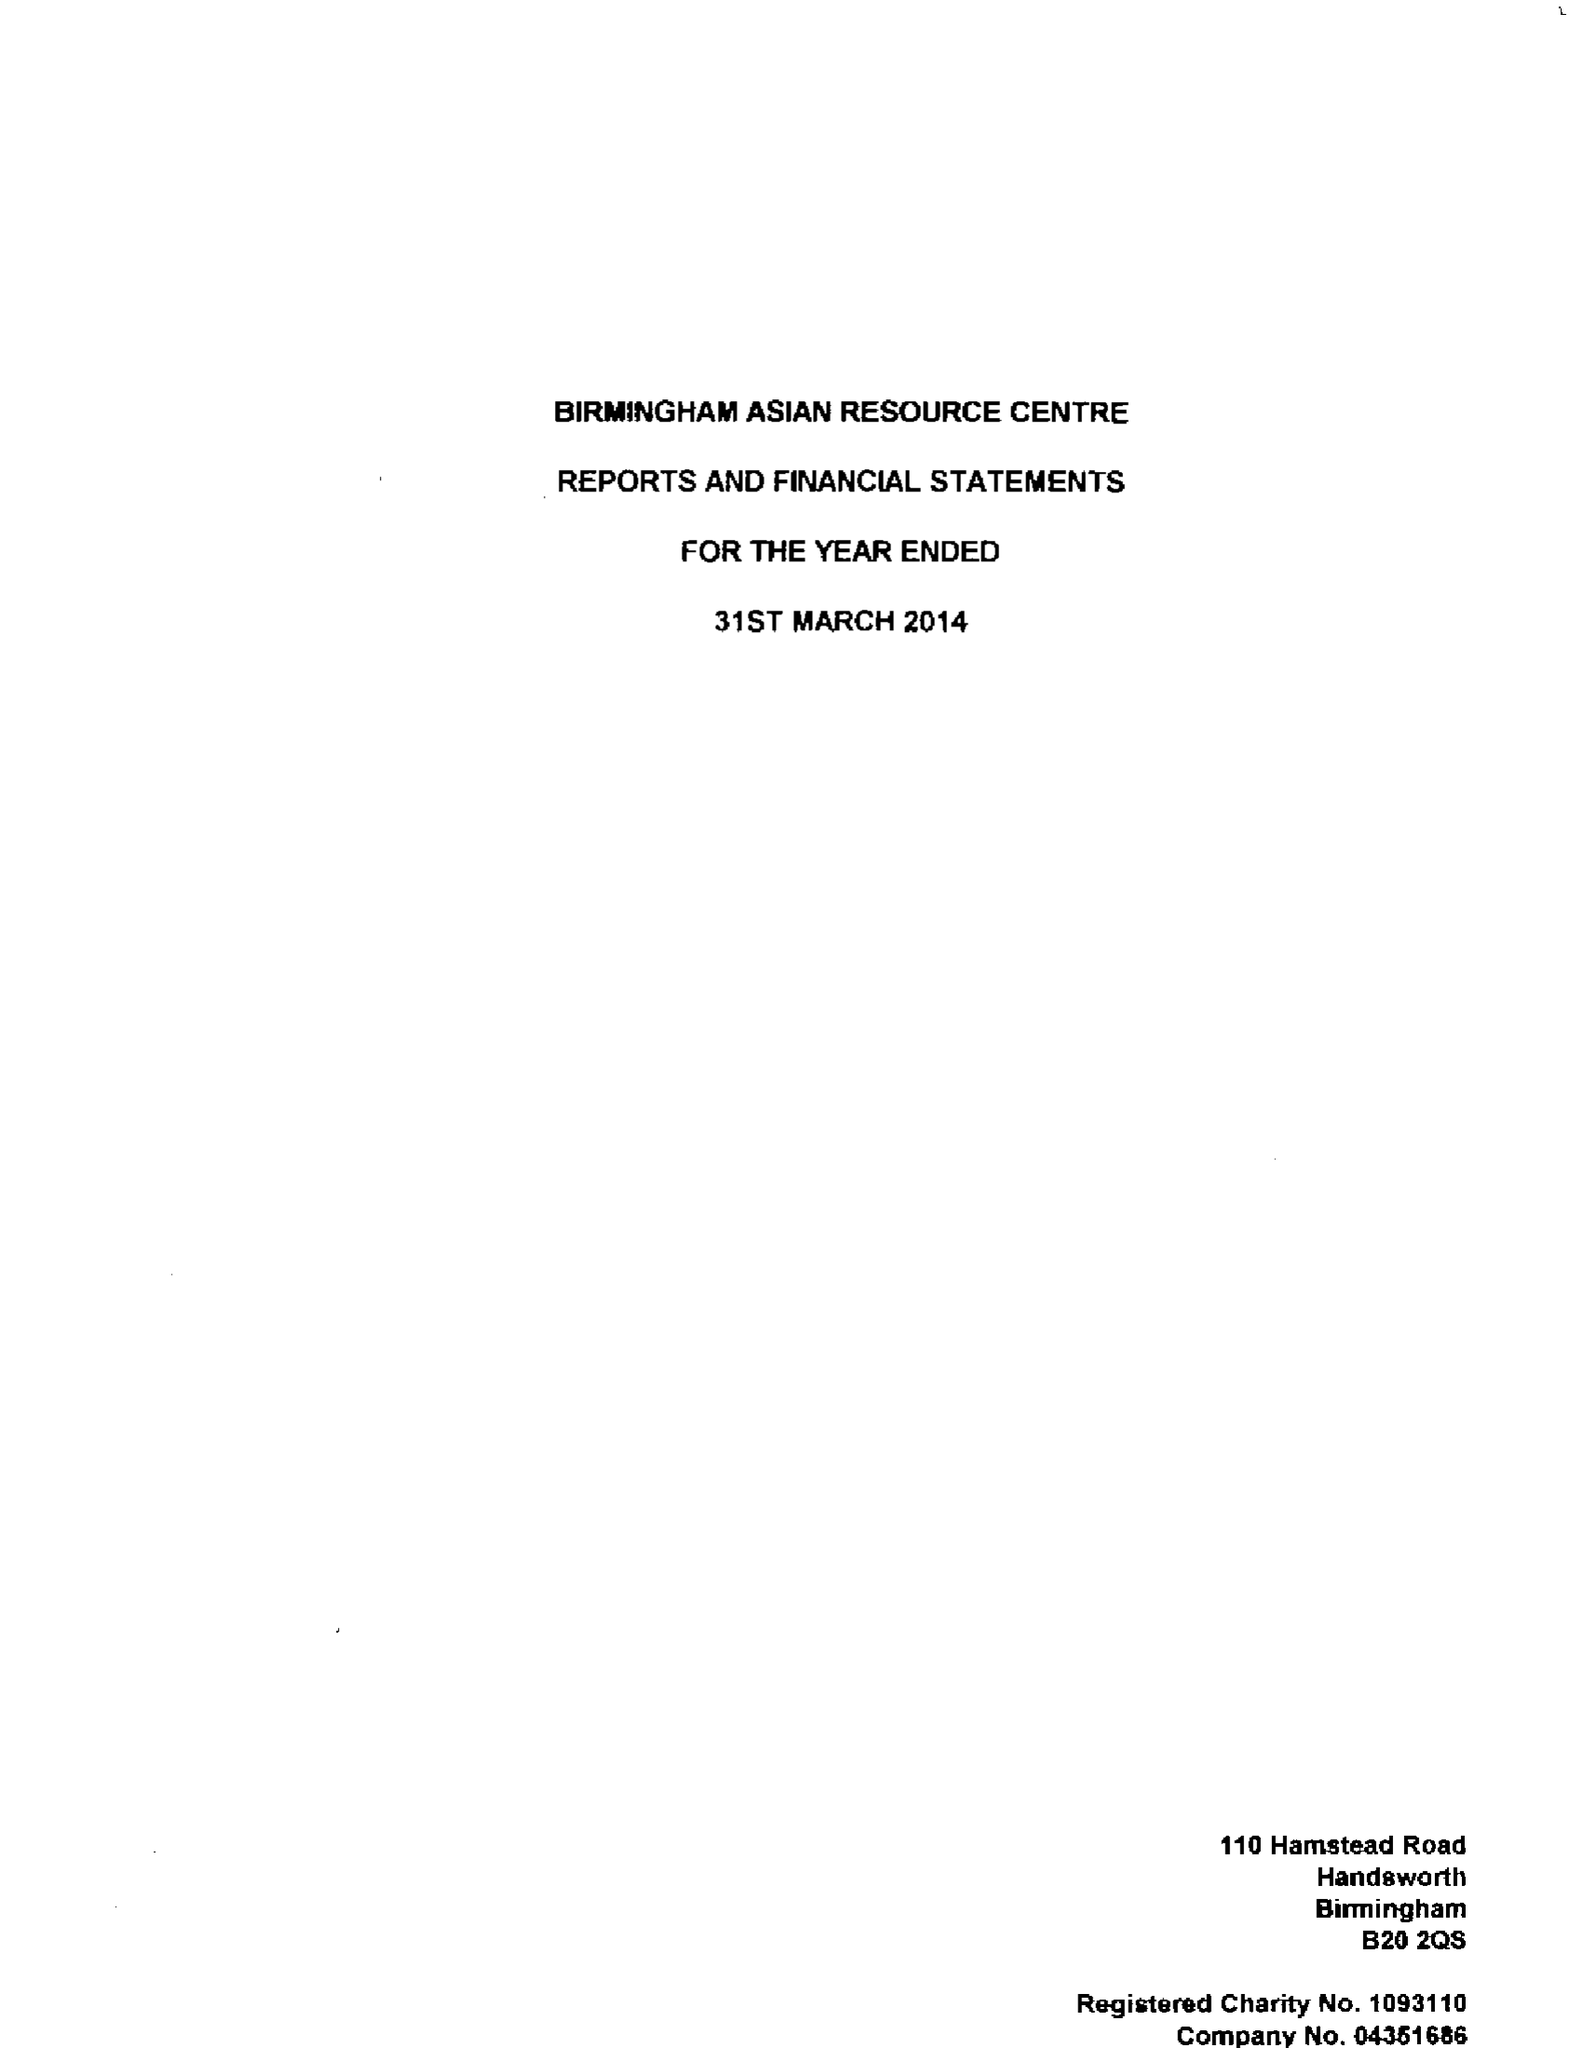What is the value for the address__postcode?
Answer the question using a single word or phrase. B20 2QS 